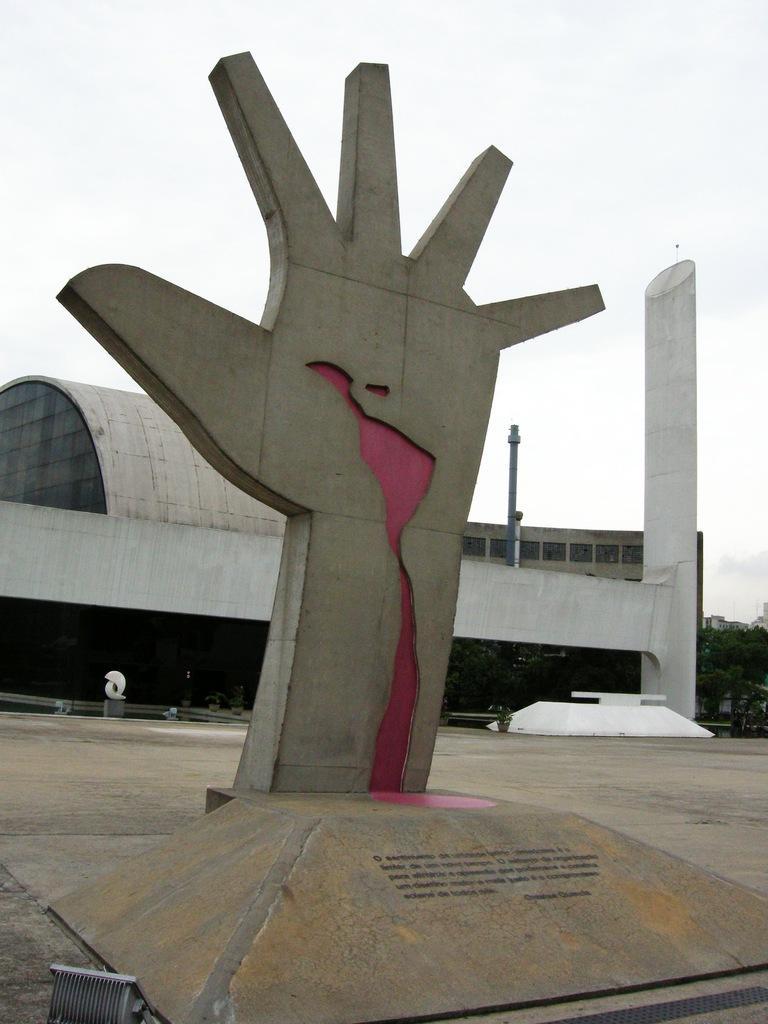In one or two sentences, can you explain what this image depicts? In this picture we can see statue of a hand on the platform. In the background of the image we can see building, trees, pole and sky. 